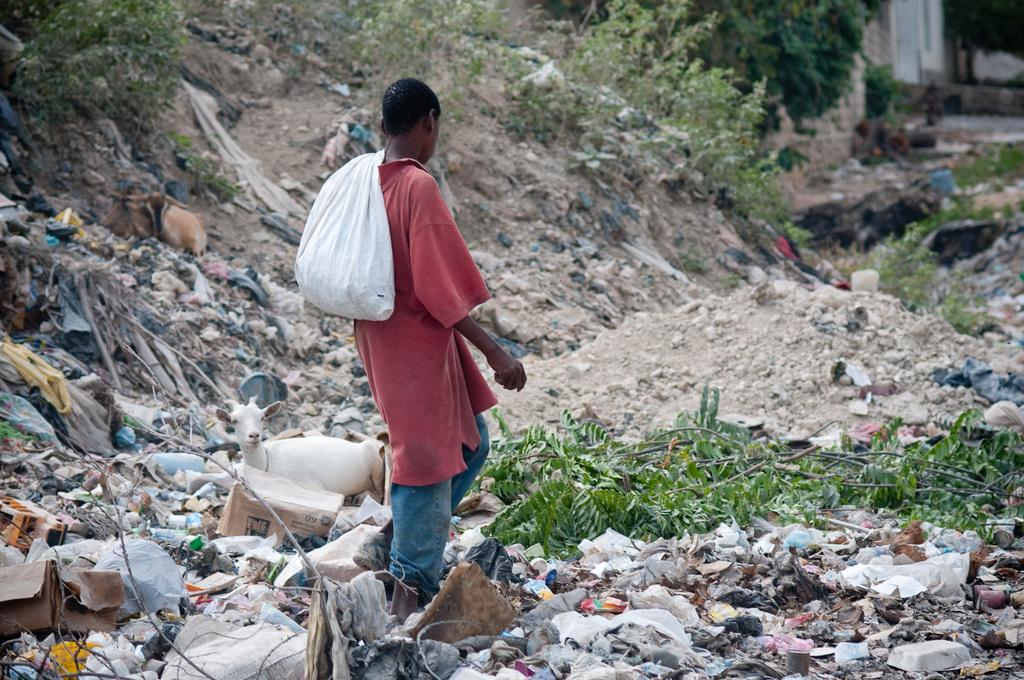What is the person holding in the image? The person is holding a cover. What can be seen on the ground in the image? There is waste on the ground. What type of animal is present in the image? There is a goat in the image. What else can be seen in the image besides the person, waste, and goat? There are plants in the image. What sound can be heard coming from the goat in the image? There is no sound coming from the goat in the image, as it is a still image and not a video or audio recording. How much has the amount of dust increased in the image? There is no mention of dust in the provided facts, so it cannot be determined if the amount of dust has increased or not. 